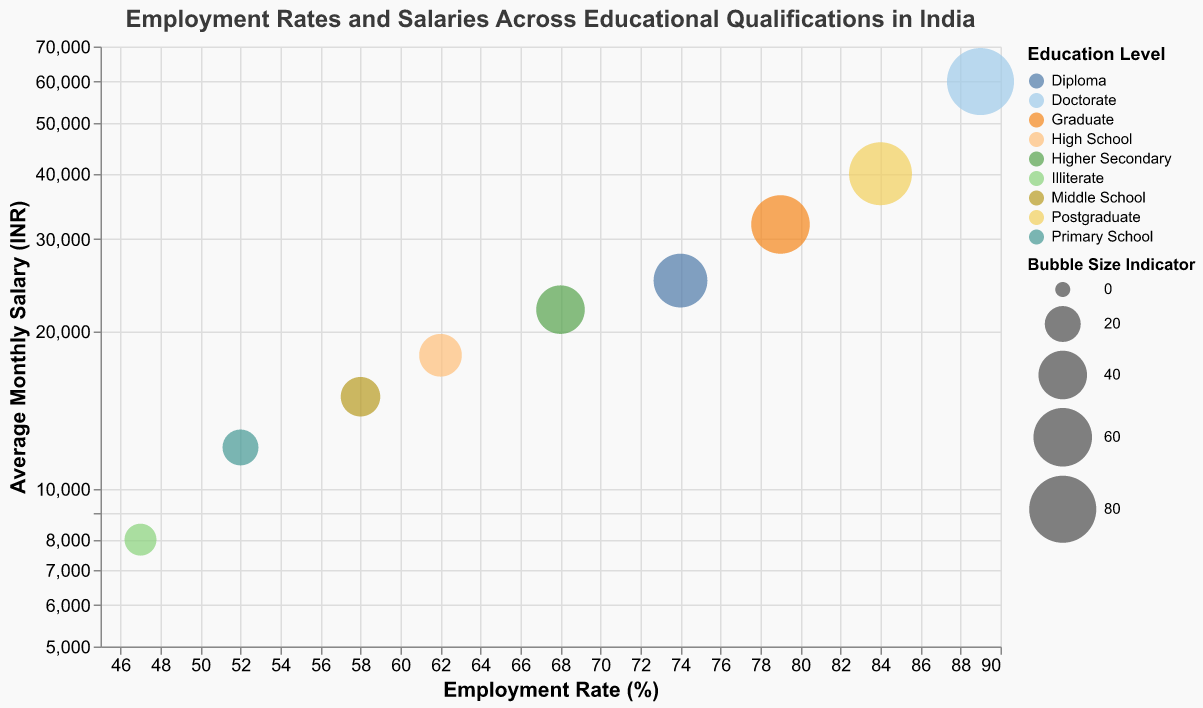What is the title of the chart? The title of the chart is written at the top in larger font size and darker color. It provides an overview of what the chart represents.
Answer: "Employment Rates and Salaries Across Educational Qualifications in India" How many education levels are depicted in the chart? Count the distinct color-coded bubbles representing different education levels on the plot. There are eight different colors corresponding to various education levels.
Answer: 9 Which education level has the highest employment rate? Look at the x-axis and identify the bubble positioned the farthest to the right. The "Doctorate" level bubble is closest to the rightmost end of the x-axis.
Answer: Doctorate What is the average monthly salary for those with a "Diploma"? Locate the "Diploma" bubble in the chart and refer to the y-axis value where this bubble is situated. The "Diploma" bubble is near the INR 25000 mark.
Answer: 25000 INR What is the difference in average monthly salary between a "Graduate" and a "Postgraduate"? Identify the y-axis positions of the "Graduate" and "Postgraduate" bubbles and calculate the difference. Graduate salary is INR 32000 and Postgraduate salary is INR 40000. The difference is 40000 - 32000.
Answer: 8000 INR Which education level is represented by the largest bubble? Compare the sizes of all bubbles; the size is indicated visually by the relative area of each circle. The largest bubble corresponds to "Doctorate".
Answer: Doctorate Between "Higher Secondary" and "High School", which has a higher employment rate and what's the difference? Compare the x-axis positions of "Higher Secondary" and "High School" bubbles. "Higher Secondary" is at 68%, and "High School" is at 62%. The difference is 68 - 62.
Answer: Higher Secondary by 6% What are the employment rate and average monthly salary for an "Illiterate" person? Locate the "Illiterate" bubble and read the corresponding values from the x and y axes. The employment rate is 47%, and the average monthly salary is INR 8000.
Answer: 47% and 8000 INR How does the average salary change from "Primary School" to "Middle School"? Compare the y-axis values of "Primary School" (INR 12000) and "Middle School" (INR 15000). The average salary increases from INR 12000 to INR 15000.
Answer: Increases by 3000 INR 